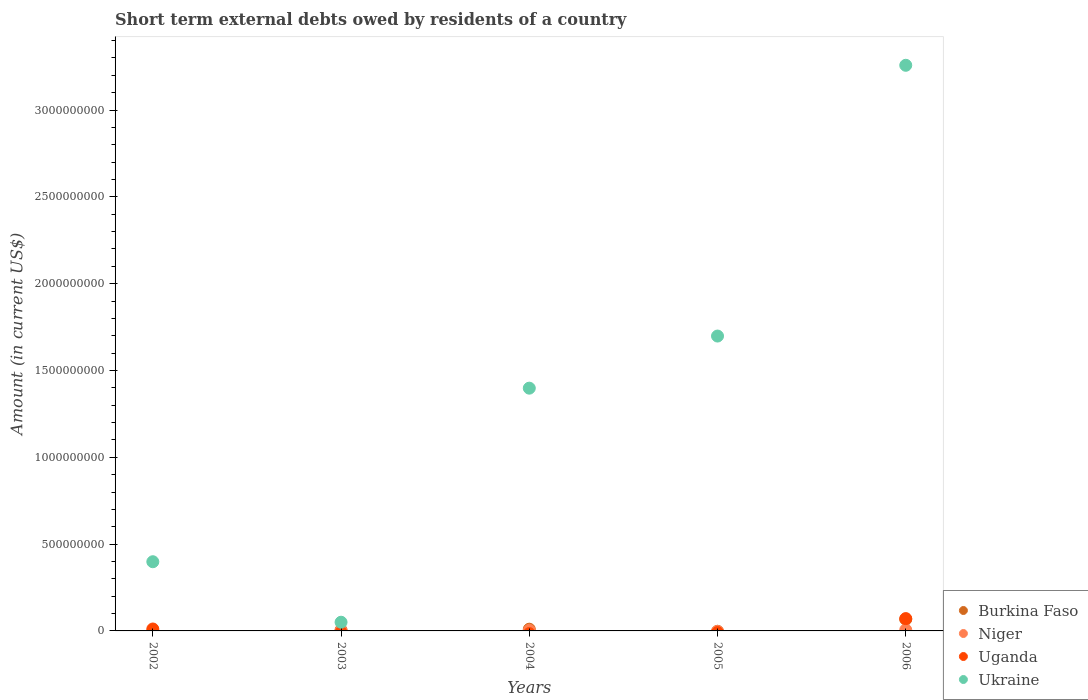How many different coloured dotlines are there?
Offer a terse response. 4. Is the number of dotlines equal to the number of legend labels?
Make the answer very short. No. What is the amount of short-term external debts owed by residents in Uganda in 2006?
Give a very brief answer. 7.10e+07. Across all years, what is the maximum amount of short-term external debts owed by residents in Niger?
Keep it short and to the point. 6.00e+06. In which year was the amount of short-term external debts owed by residents in Niger maximum?
Provide a short and direct response. 2006. What is the total amount of short-term external debts owed by residents in Burkina Faso in the graph?
Offer a very short reply. 8.20e+07. What is the difference between the amount of short-term external debts owed by residents in Ukraine in 2004 and that in 2006?
Keep it short and to the point. -1.86e+09. What is the difference between the amount of short-term external debts owed by residents in Niger in 2004 and the amount of short-term external debts owed by residents in Uganda in 2005?
Offer a terse response. 3.30e+06. What is the average amount of short-term external debts owed by residents in Niger per year?
Keep it short and to the point. 2.17e+06. In the year 2004, what is the difference between the amount of short-term external debts owed by residents in Ukraine and amount of short-term external debts owed by residents in Niger?
Ensure brevity in your answer.  1.39e+09. In how many years, is the amount of short-term external debts owed by residents in Niger greater than 100000000 US$?
Keep it short and to the point. 0. What is the ratio of the amount of short-term external debts owed by residents in Ukraine in 2004 to that in 2005?
Give a very brief answer. 0.82. What is the difference between the highest and the second highest amount of short-term external debts owed by residents in Ukraine?
Offer a terse response. 1.56e+09. What is the difference between the highest and the lowest amount of short-term external debts owed by residents in Niger?
Make the answer very short. 6.00e+06. Is it the case that in every year, the sum of the amount of short-term external debts owed by residents in Niger and amount of short-term external debts owed by residents in Burkina Faso  is greater than the sum of amount of short-term external debts owed by residents in Uganda and amount of short-term external debts owed by residents in Ukraine?
Keep it short and to the point. No. Is it the case that in every year, the sum of the amount of short-term external debts owed by residents in Ukraine and amount of short-term external debts owed by residents in Niger  is greater than the amount of short-term external debts owed by residents in Burkina Faso?
Ensure brevity in your answer.  Yes. Does the amount of short-term external debts owed by residents in Ukraine monotonically increase over the years?
Keep it short and to the point. No. Is the amount of short-term external debts owed by residents in Ukraine strictly greater than the amount of short-term external debts owed by residents in Niger over the years?
Offer a very short reply. Yes. Is the amount of short-term external debts owed by residents in Ukraine strictly less than the amount of short-term external debts owed by residents in Uganda over the years?
Your answer should be compact. No. How many dotlines are there?
Offer a terse response. 4. What is the difference between two consecutive major ticks on the Y-axis?
Offer a very short reply. 5.00e+08. Are the values on the major ticks of Y-axis written in scientific E-notation?
Give a very brief answer. No. Does the graph contain grids?
Offer a very short reply. No. How many legend labels are there?
Keep it short and to the point. 4. How are the legend labels stacked?
Make the answer very short. Vertical. What is the title of the graph?
Offer a very short reply. Short term external debts owed by residents of a country. Does "Senegal" appear as one of the legend labels in the graph?
Your answer should be compact. No. What is the Amount (in current US$) of Niger in 2002?
Offer a terse response. 0. What is the Amount (in current US$) of Uganda in 2002?
Ensure brevity in your answer.  1.11e+07. What is the Amount (in current US$) of Ukraine in 2002?
Ensure brevity in your answer.  3.99e+08. What is the Amount (in current US$) of Burkina Faso in 2003?
Make the answer very short. 5.00e+06. What is the Amount (in current US$) of Niger in 2003?
Your answer should be very brief. 1.54e+06. What is the Amount (in current US$) of Ukraine in 2003?
Offer a terse response. 5.01e+07. What is the Amount (in current US$) of Burkina Faso in 2004?
Give a very brief answer. 1.00e+07. What is the Amount (in current US$) in Niger in 2004?
Offer a very short reply. 3.30e+06. What is the Amount (in current US$) in Uganda in 2004?
Keep it short and to the point. 0. What is the Amount (in current US$) of Ukraine in 2004?
Make the answer very short. 1.40e+09. What is the Amount (in current US$) of Uganda in 2005?
Provide a short and direct response. 0. What is the Amount (in current US$) in Ukraine in 2005?
Provide a short and direct response. 1.70e+09. What is the Amount (in current US$) in Burkina Faso in 2006?
Provide a short and direct response. 6.70e+07. What is the Amount (in current US$) in Niger in 2006?
Provide a succinct answer. 6.00e+06. What is the Amount (in current US$) of Uganda in 2006?
Provide a short and direct response. 7.10e+07. What is the Amount (in current US$) of Ukraine in 2006?
Offer a terse response. 3.26e+09. Across all years, what is the maximum Amount (in current US$) of Burkina Faso?
Provide a short and direct response. 6.70e+07. Across all years, what is the maximum Amount (in current US$) in Uganda?
Your response must be concise. 7.10e+07. Across all years, what is the maximum Amount (in current US$) of Ukraine?
Ensure brevity in your answer.  3.26e+09. Across all years, what is the minimum Amount (in current US$) in Burkina Faso?
Provide a succinct answer. 0. Across all years, what is the minimum Amount (in current US$) of Ukraine?
Provide a short and direct response. 5.01e+07. What is the total Amount (in current US$) of Burkina Faso in the graph?
Give a very brief answer. 8.20e+07. What is the total Amount (in current US$) in Niger in the graph?
Your answer should be compact. 1.08e+07. What is the total Amount (in current US$) in Uganda in the graph?
Make the answer very short. 8.21e+07. What is the total Amount (in current US$) in Ukraine in the graph?
Your answer should be compact. 6.80e+09. What is the difference between the Amount (in current US$) of Ukraine in 2002 and that in 2003?
Give a very brief answer. 3.48e+08. What is the difference between the Amount (in current US$) in Ukraine in 2002 and that in 2004?
Your answer should be very brief. -1.00e+09. What is the difference between the Amount (in current US$) of Ukraine in 2002 and that in 2005?
Offer a terse response. -1.30e+09. What is the difference between the Amount (in current US$) of Uganda in 2002 and that in 2006?
Your answer should be compact. -5.99e+07. What is the difference between the Amount (in current US$) of Ukraine in 2002 and that in 2006?
Make the answer very short. -2.86e+09. What is the difference between the Amount (in current US$) of Burkina Faso in 2003 and that in 2004?
Your answer should be compact. -5.00e+06. What is the difference between the Amount (in current US$) of Niger in 2003 and that in 2004?
Your response must be concise. -1.76e+06. What is the difference between the Amount (in current US$) of Ukraine in 2003 and that in 2004?
Offer a terse response. -1.35e+09. What is the difference between the Amount (in current US$) in Ukraine in 2003 and that in 2005?
Provide a succinct answer. -1.65e+09. What is the difference between the Amount (in current US$) in Burkina Faso in 2003 and that in 2006?
Provide a succinct answer. -6.20e+07. What is the difference between the Amount (in current US$) in Niger in 2003 and that in 2006?
Make the answer very short. -4.46e+06. What is the difference between the Amount (in current US$) of Ukraine in 2003 and that in 2006?
Provide a succinct answer. -3.21e+09. What is the difference between the Amount (in current US$) in Ukraine in 2004 and that in 2005?
Your answer should be compact. -3.00e+08. What is the difference between the Amount (in current US$) in Burkina Faso in 2004 and that in 2006?
Give a very brief answer. -5.70e+07. What is the difference between the Amount (in current US$) in Niger in 2004 and that in 2006?
Your answer should be very brief. -2.70e+06. What is the difference between the Amount (in current US$) of Ukraine in 2004 and that in 2006?
Your answer should be compact. -1.86e+09. What is the difference between the Amount (in current US$) in Ukraine in 2005 and that in 2006?
Provide a short and direct response. -1.56e+09. What is the difference between the Amount (in current US$) of Uganda in 2002 and the Amount (in current US$) of Ukraine in 2003?
Provide a short and direct response. -3.90e+07. What is the difference between the Amount (in current US$) in Uganda in 2002 and the Amount (in current US$) in Ukraine in 2004?
Give a very brief answer. -1.39e+09. What is the difference between the Amount (in current US$) in Uganda in 2002 and the Amount (in current US$) in Ukraine in 2005?
Your answer should be very brief. -1.69e+09. What is the difference between the Amount (in current US$) of Uganda in 2002 and the Amount (in current US$) of Ukraine in 2006?
Make the answer very short. -3.25e+09. What is the difference between the Amount (in current US$) in Burkina Faso in 2003 and the Amount (in current US$) in Niger in 2004?
Give a very brief answer. 1.70e+06. What is the difference between the Amount (in current US$) of Burkina Faso in 2003 and the Amount (in current US$) of Ukraine in 2004?
Offer a very short reply. -1.39e+09. What is the difference between the Amount (in current US$) of Niger in 2003 and the Amount (in current US$) of Ukraine in 2004?
Offer a terse response. -1.40e+09. What is the difference between the Amount (in current US$) in Burkina Faso in 2003 and the Amount (in current US$) in Ukraine in 2005?
Offer a terse response. -1.69e+09. What is the difference between the Amount (in current US$) in Niger in 2003 and the Amount (in current US$) in Ukraine in 2005?
Your response must be concise. -1.70e+09. What is the difference between the Amount (in current US$) in Burkina Faso in 2003 and the Amount (in current US$) in Uganda in 2006?
Your answer should be very brief. -6.60e+07. What is the difference between the Amount (in current US$) of Burkina Faso in 2003 and the Amount (in current US$) of Ukraine in 2006?
Give a very brief answer. -3.25e+09. What is the difference between the Amount (in current US$) of Niger in 2003 and the Amount (in current US$) of Uganda in 2006?
Your answer should be very brief. -6.95e+07. What is the difference between the Amount (in current US$) in Niger in 2003 and the Amount (in current US$) in Ukraine in 2006?
Your answer should be very brief. -3.26e+09. What is the difference between the Amount (in current US$) in Burkina Faso in 2004 and the Amount (in current US$) in Ukraine in 2005?
Your response must be concise. -1.69e+09. What is the difference between the Amount (in current US$) of Niger in 2004 and the Amount (in current US$) of Ukraine in 2005?
Offer a terse response. -1.70e+09. What is the difference between the Amount (in current US$) in Burkina Faso in 2004 and the Amount (in current US$) in Niger in 2006?
Your answer should be very brief. 4.00e+06. What is the difference between the Amount (in current US$) of Burkina Faso in 2004 and the Amount (in current US$) of Uganda in 2006?
Give a very brief answer. -6.10e+07. What is the difference between the Amount (in current US$) in Burkina Faso in 2004 and the Amount (in current US$) in Ukraine in 2006?
Your response must be concise. -3.25e+09. What is the difference between the Amount (in current US$) in Niger in 2004 and the Amount (in current US$) in Uganda in 2006?
Offer a very short reply. -6.77e+07. What is the difference between the Amount (in current US$) of Niger in 2004 and the Amount (in current US$) of Ukraine in 2006?
Make the answer very short. -3.25e+09. What is the average Amount (in current US$) in Burkina Faso per year?
Make the answer very short. 1.64e+07. What is the average Amount (in current US$) of Niger per year?
Your answer should be very brief. 2.17e+06. What is the average Amount (in current US$) in Uganda per year?
Give a very brief answer. 1.64e+07. What is the average Amount (in current US$) of Ukraine per year?
Your answer should be compact. 1.36e+09. In the year 2002, what is the difference between the Amount (in current US$) in Uganda and Amount (in current US$) in Ukraine?
Ensure brevity in your answer.  -3.87e+08. In the year 2003, what is the difference between the Amount (in current US$) of Burkina Faso and Amount (in current US$) of Niger?
Offer a very short reply. 3.46e+06. In the year 2003, what is the difference between the Amount (in current US$) in Burkina Faso and Amount (in current US$) in Ukraine?
Ensure brevity in your answer.  -4.51e+07. In the year 2003, what is the difference between the Amount (in current US$) of Niger and Amount (in current US$) of Ukraine?
Provide a succinct answer. -4.86e+07. In the year 2004, what is the difference between the Amount (in current US$) in Burkina Faso and Amount (in current US$) in Niger?
Offer a very short reply. 6.70e+06. In the year 2004, what is the difference between the Amount (in current US$) in Burkina Faso and Amount (in current US$) in Ukraine?
Provide a succinct answer. -1.39e+09. In the year 2004, what is the difference between the Amount (in current US$) of Niger and Amount (in current US$) of Ukraine?
Make the answer very short. -1.39e+09. In the year 2006, what is the difference between the Amount (in current US$) of Burkina Faso and Amount (in current US$) of Niger?
Keep it short and to the point. 6.10e+07. In the year 2006, what is the difference between the Amount (in current US$) in Burkina Faso and Amount (in current US$) in Uganda?
Keep it short and to the point. -4.00e+06. In the year 2006, what is the difference between the Amount (in current US$) of Burkina Faso and Amount (in current US$) of Ukraine?
Provide a succinct answer. -3.19e+09. In the year 2006, what is the difference between the Amount (in current US$) in Niger and Amount (in current US$) in Uganda?
Provide a short and direct response. -6.50e+07. In the year 2006, what is the difference between the Amount (in current US$) in Niger and Amount (in current US$) in Ukraine?
Give a very brief answer. -3.25e+09. In the year 2006, what is the difference between the Amount (in current US$) of Uganda and Amount (in current US$) of Ukraine?
Your answer should be very brief. -3.19e+09. What is the ratio of the Amount (in current US$) in Ukraine in 2002 to that in 2003?
Offer a very short reply. 7.95. What is the ratio of the Amount (in current US$) in Ukraine in 2002 to that in 2004?
Ensure brevity in your answer.  0.28. What is the ratio of the Amount (in current US$) of Ukraine in 2002 to that in 2005?
Give a very brief answer. 0.23. What is the ratio of the Amount (in current US$) of Uganda in 2002 to that in 2006?
Offer a terse response. 0.16. What is the ratio of the Amount (in current US$) in Ukraine in 2002 to that in 2006?
Give a very brief answer. 0.12. What is the ratio of the Amount (in current US$) of Burkina Faso in 2003 to that in 2004?
Make the answer very short. 0.5. What is the ratio of the Amount (in current US$) of Niger in 2003 to that in 2004?
Provide a short and direct response. 0.47. What is the ratio of the Amount (in current US$) in Ukraine in 2003 to that in 2004?
Keep it short and to the point. 0.04. What is the ratio of the Amount (in current US$) in Ukraine in 2003 to that in 2005?
Make the answer very short. 0.03. What is the ratio of the Amount (in current US$) in Burkina Faso in 2003 to that in 2006?
Offer a very short reply. 0.07. What is the ratio of the Amount (in current US$) in Niger in 2003 to that in 2006?
Your response must be concise. 0.26. What is the ratio of the Amount (in current US$) of Ukraine in 2003 to that in 2006?
Give a very brief answer. 0.02. What is the ratio of the Amount (in current US$) of Ukraine in 2004 to that in 2005?
Keep it short and to the point. 0.82. What is the ratio of the Amount (in current US$) of Burkina Faso in 2004 to that in 2006?
Your answer should be compact. 0.15. What is the ratio of the Amount (in current US$) in Niger in 2004 to that in 2006?
Give a very brief answer. 0.55. What is the ratio of the Amount (in current US$) of Ukraine in 2004 to that in 2006?
Make the answer very short. 0.43. What is the ratio of the Amount (in current US$) in Ukraine in 2005 to that in 2006?
Offer a very short reply. 0.52. What is the difference between the highest and the second highest Amount (in current US$) of Burkina Faso?
Keep it short and to the point. 5.70e+07. What is the difference between the highest and the second highest Amount (in current US$) of Niger?
Provide a succinct answer. 2.70e+06. What is the difference between the highest and the second highest Amount (in current US$) in Ukraine?
Offer a very short reply. 1.56e+09. What is the difference between the highest and the lowest Amount (in current US$) of Burkina Faso?
Keep it short and to the point. 6.70e+07. What is the difference between the highest and the lowest Amount (in current US$) of Niger?
Your answer should be very brief. 6.00e+06. What is the difference between the highest and the lowest Amount (in current US$) in Uganda?
Offer a very short reply. 7.10e+07. What is the difference between the highest and the lowest Amount (in current US$) of Ukraine?
Offer a very short reply. 3.21e+09. 